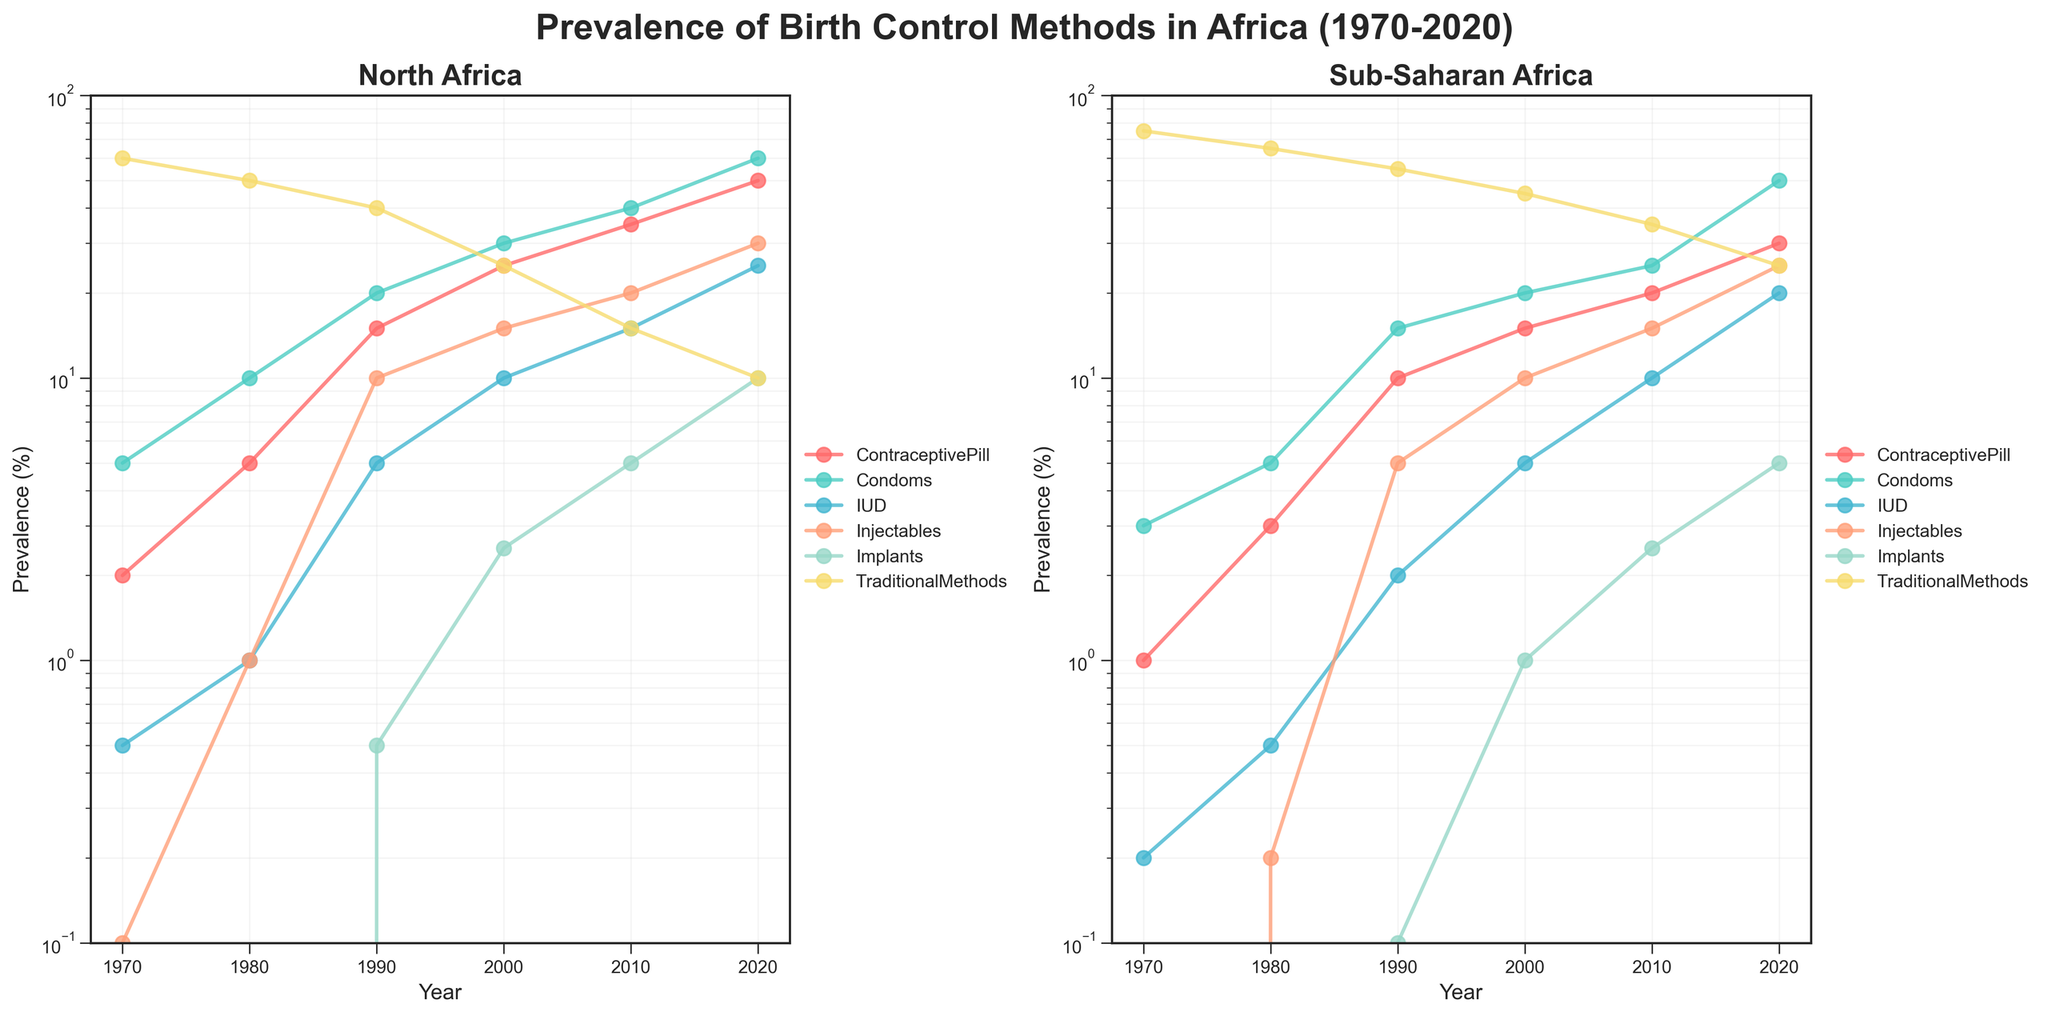What is the title of the plot? The title is usually located at the top of the figure and provides a summary of what the plot is about.
Answer: Prevalence of Birth Control Methods in Africa (1970-2020) Which birth control method had the highest prevalence in Sub-Saharan Africa in 1970? Examine the data points for each method in Sub-Saharan Africa for the year 1970 to find the one with the highest prevalence.
Answer: TraditionalMethods How did the prevalence of the contraceptive pill change in North Africa from 1970 to 2020? Compare the data points for the contraceptive pill for North Africa between the years 1970 and 2020 to observe the change.
Answer: Increased from 2% to 50% In which year did North Africa have a higher prevalence of IUDs compared to Sub-Saharan Africa? Review the prevalence of IUDs for both regions across all years and identify the periods where North Africa had higher values.
Answer: 1980, 1990, 2000, 2010, 2020 Which region had a more significant increase in the use of condoms between 1970 and 2020? Calculate the difference in condom prevalence from 1970 to 2020 for both regions and compare the increases.
Answer: North Africa What is the ratio of injectable prevalence in North Africa to Sub-Saharan Africa in 2020? Divide the prevalence of injectables in North Africa by that in Sub-Saharan Africa for the year 2020.
Answer: 30/25 = 1.2 What method showed the least change in prevalence from 1970 to 2020 in Sub-Saharan Africa? Examine the changes in prevalence for each method in Sub-Saharan Africa from 1970 to 2020 and identify the method with the smallest change.
Answer: TraditionalMethods What is the overall trend for implant use in both regions over the 50-year period? Assess the data points for implant use in both regions over time to identify any general upward or downward trends.
Answer: Increasing In which decade did North Africa see the most significant increase in contraceptive pill use? Determine the decade with the largest increase in contraceptive pill prevalence by comparing data points for consecutive decades.
Answer: 1980s to 1990s 